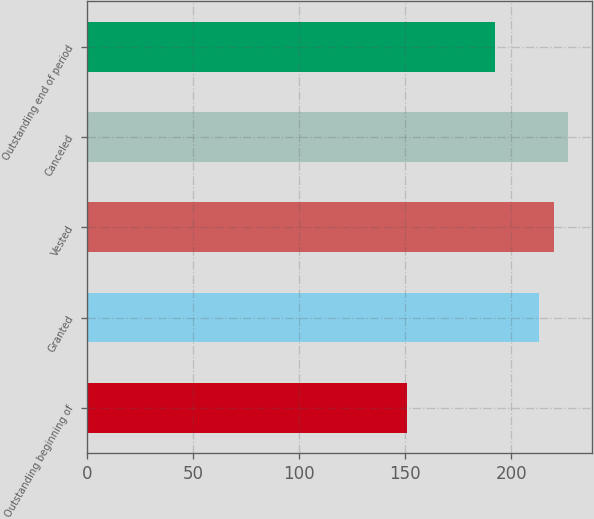Convert chart to OTSL. <chart><loc_0><loc_0><loc_500><loc_500><bar_chart><fcel>Outstanding beginning of<fcel>Granted<fcel>Vested<fcel>Canceled<fcel>Outstanding end of period<nl><fcel>150.96<fcel>213.09<fcel>219.99<fcel>226.89<fcel>192.41<nl></chart> 